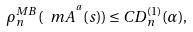Convert formula to latex. <formula><loc_0><loc_0><loc_500><loc_500>\rho _ { n } ^ { M B } ( \ m A ^ { ^ { a } } ( s ) ) \leq C D _ { n } ^ { ( 1 ) } ( \alpha ) ,</formula> 